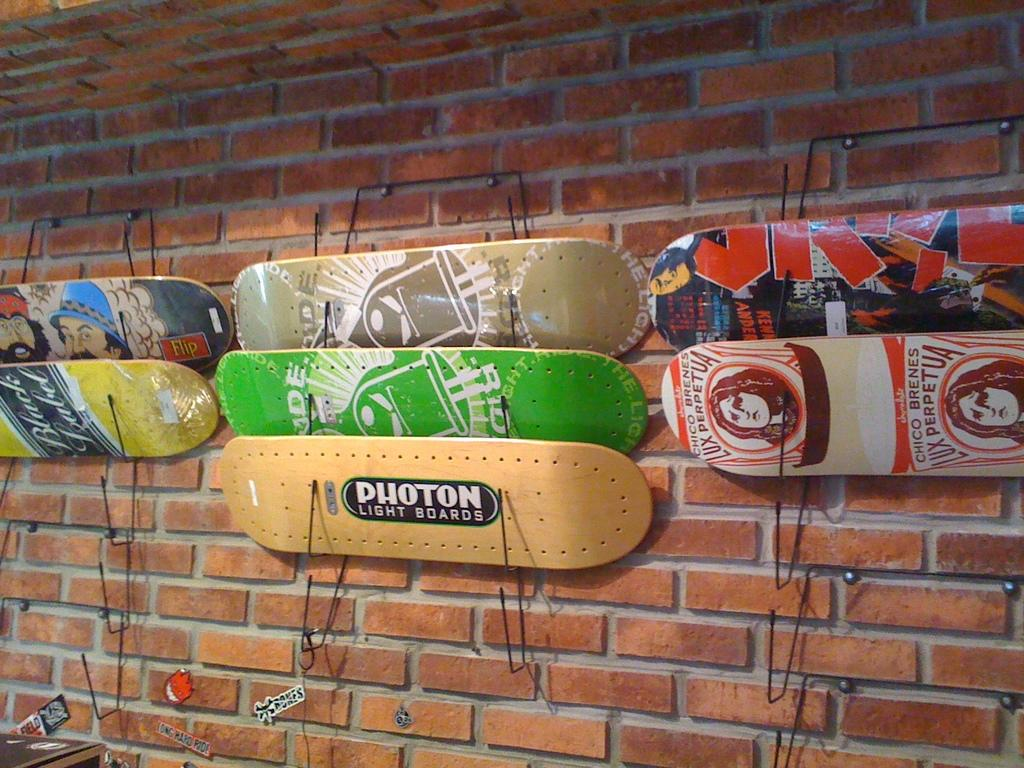What is attached to the wall in the image? There are boards on a wall in the image. Can you describe any objects that are visible in the image? Unfortunately, the provided facts only mention that there are objects in the image, but no specific details are given. What type of glue is being used to hold the boards together in the image? There is no information about glue or how the boards are attached in the image. 